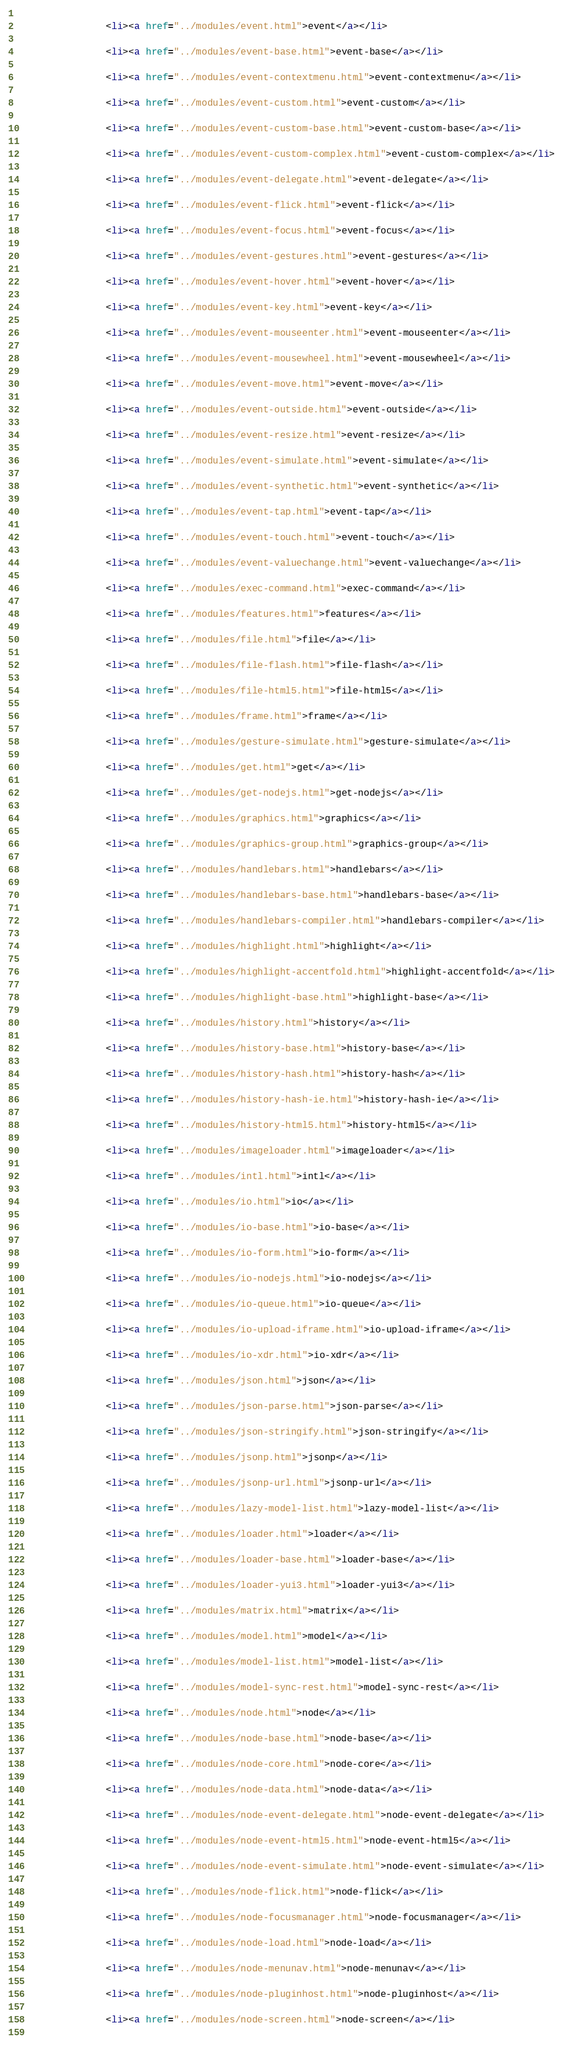Convert code to text. <code><loc_0><loc_0><loc_500><loc_500><_HTML_>            
                <li><a href="../modules/event.html">event</a></li>
            
                <li><a href="../modules/event-base.html">event-base</a></li>
            
                <li><a href="../modules/event-contextmenu.html">event-contextmenu</a></li>
            
                <li><a href="../modules/event-custom.html">event-custom</a></li>
            
                <li><a href="../modules/event-custom-base.html">event-custom-base</a></li>
            
                <li><a href="../modules/event-custom-complex.html">event-custom-complex</a></li>
            
                <li><a href="../modules/event-delegate.html">event-delegate</a></li>
            
                <li><a href="../modules/event-flick.html">event-flick</a></li>
            
                <li><a href="../modules/event-focus.html">event-focus</a></li>
            
                <li><a href="../modules/event-gestures.html">event-gestures</a></li>
            
                <li><a href="../modules/event-hover.html">event-hover</a></li>
            
                <li><a href="../modules/event-key.html">event-key</a></li>
            
                <li><a href="../modules/event-mouseenter.html">event-mouseenter</a></li>
            
                <li><a href="../modules/event-mousewheel.html">event-mousewheel</a></li>
            
                <li><a href="../modules/event-move.html">event-move</a></li>
            
                <li><a href="../modules/event-outside.html">event-outside</a></li>
            
                <li><a href="../modules/event-resize.html">event-resize</a></li>
            
                <li><a href="../modules/event-simulate.html">event-simulate</a></li>
            
                <li><a href="../modules/event-synthetic.html">event-synthetic</a></li>
            
                <li><a href="../modules/event-tap.html">event-tap</a></li>
            
                <li><a href="../modules/event-touch.html">event-touch</a></li>
            
                <li><a href="../modules/event-valuechange.html">event-valuechange</a></li>
            
                <li><a href="../modules/exec-command.html">exec-command</a></li>
            
                <li><a href="../modules/features.html">features</a></li>
            
                <li><a href="../modules/file.html">file</a></li>
            
                <li><a href="../modules/file-flash.html">file-flash</a></li>
            
                <li><a href="../modules/file-html5.html">file-html5</a></li>
            
                <li><a href="../modules/frame.html">frame</a></li>
            
                <li><a href="../modules/gesture-simulate.html">gesture-simulate</a></li>
            
                <li><a href="../modules/get.html">get</a></li>
            
                <li><a href="../modules/get-nodejs.html">get-nodejs</a></li>
            
                <li><a href="../modules/graphics.html">graphics</a></li>
            
                <li><a href="../modules/graphics-group.html">graphics-group</a></li>
            
                <li><a href="../modules/handlebars.html">handlebars</a></li>
            
                <li><a href="../modules/handlebars-base.html">handlebars-base</a></li>
            
                <li><a href="../modules/handlebars-compiler.html">handlebars-compiler</a></li>
            
                <li><a href="../modules/highlight.html">highlight</a></li>
            
                <li><a href="../modules/highlight-accentfold.html">highlight-accentfold</a></li>
            
                <li><a href="../modules/highlight-base.html">highlight-base</a></li>
            
                <li><a href="../modules/history.html">history</a></li>
            
                <li><a href="../modules/history-base.html">history-base</a></li>
            
                <li><a href="../modules/history-hash.html">history-hash</a></li>
            
                <li><a href="../modules/history-hash-ie.html">history-hash-ie</a></li>
            
                <li><a href="../modules/history-html5.html">history-html5</a></li>
            
                <li><a href="../modules/imageloader.html">imageloader</a></li>
            
                <li><a href="../modules/intl.html">intl</a></li>
            
                <li><a href="../modules/io.html">io</a></li>
            
                <li><a href="../modules/io-base.html">io-base</a></li>
            
                <li><a href="../modules/io-form.html">io-form</a></li>
            
                <li><a href="../modules/io-nodejs.html">io-nodejs</a></li>
            
                <li><a href="../modules/io-queue.html">io-queue</a></li>
            
                <li><a href="../modules/io-upload-iframe.html">io-upload-iframe</a></li>
            
                <li><a href="../modules/io-xdr.html">io-xdr</a></li>
            
                <li><a href="../modules/json.html">json</a></li>
            
                <li><a href="../modules/json-parse.html">json-parse</a></li>
            
                <li><a href="../modules/json-stringify.html">json-stringify</a></li>
            
                <li><a href="../modules/jsonp.html">jsonp</a></li>
            
                <li><a href="../modules/jsonp-url.html">jsonp-url</a></li>
            
                <li><a href="../modules/lazy-model-list.html">lazy-model-list</a></li>
            
                <li><a href="../modules/loader.html">loader</a></li>
            
                <li><a href="../modules/loader-base.html">loader-base</a></li>
            
                <li><a href="../modules/loader-yui3.html">loader-yui3</a></li>
            
                <li><a href="../modules/matrix.html">matrix</a></li>
            
                <li><a href="../modules/model.html">model</a></li>
            
                <li><a href="../modules/model-list.html">model-list</a></li>
            
                <li><a href="../modules/model-sync-rest.html">model-sync-rest</a></li>
            
                <li><a href="../modules/node.html">node</a></li>
            
                <li><a href="../modules/node-base.html">node-base</a></li>
            
                <li><a href="../modules/node-core.html">node-core</a></li>
            
                <li><a href="../modules/node-data.html">node-data</a></li>
            
                <li><a href="../modules/node-event-delegate.html">node-event-delegate</a></li>
            
                <li><a href="../modules/node-event-html5.html">node-event-html5</a></li>
            
                <li><a href="../modules/node-event-simulate.html">node-event-simulate</a></li>
            
                <li><a href="../modules/node-flick.html">node-flick</a></li>
            
                <li><a href="../modules/node-focusmanager.html">node-focusmanager</a></li>
            
                <li><a href="../modules/node-load.html">node-load</a></li>
            
                <li><a href="../modules/node-menunav.html">node-menunav</a></li>
            
                <li><a href="../modules/node-pluginhost.html">node-pluginhost</a></li>
            
                <li><a href="../modules/node-screen.html">node-screen</a></li>
            </code> 